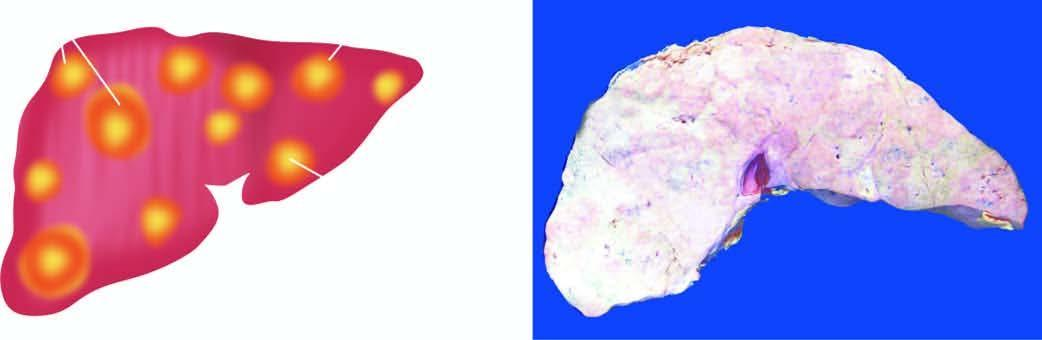what do characteristic features include?
Answer the question using a single word or phrase. Multiple 